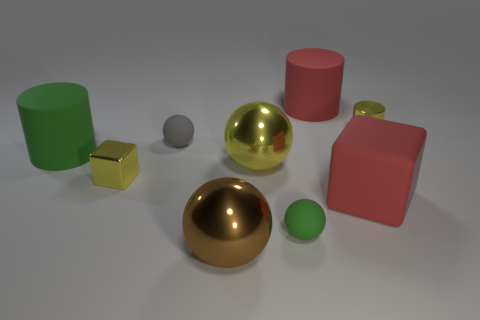What number of other things are the same size as the yellow ball?
Give a very brief answer. 4. There is a metal cube; is it the same color as the small rubber sphere that is behind the small yellow cube?
Offer a terse response. No. How many spheres are either large blue matte objects or gray objects?
Your answer should be very brief. 1. Is there anything else of the same color as the tiny metal cube?
Offer a terse response. Yes. The block that is on the left side of the tiny rubber sphere that is in front of the gray rubber sphere is made of what material?
Your response must be concise. Metal. Are the large yellow ball and the large object that is in front of the big red rubber cube made of the same material?
Offer a very short reply. Yes. How many objects are either small green spheres that are in front of the large yellow metal ball or yellow cubes?
Your answer should be very brief. 2. Are there any rubber cylinders that have the same color as the metal cylinder?
Your answer should be very brief. No. There is a tiny gray rubber thing; is its shape the same as the matte thing behind the tiny yellow metallic cylinder?
Your answer should be compact. No. What number of large objects are behind the large brown ball and in front of the green cylinder?
Offer a very short reply. 2. 